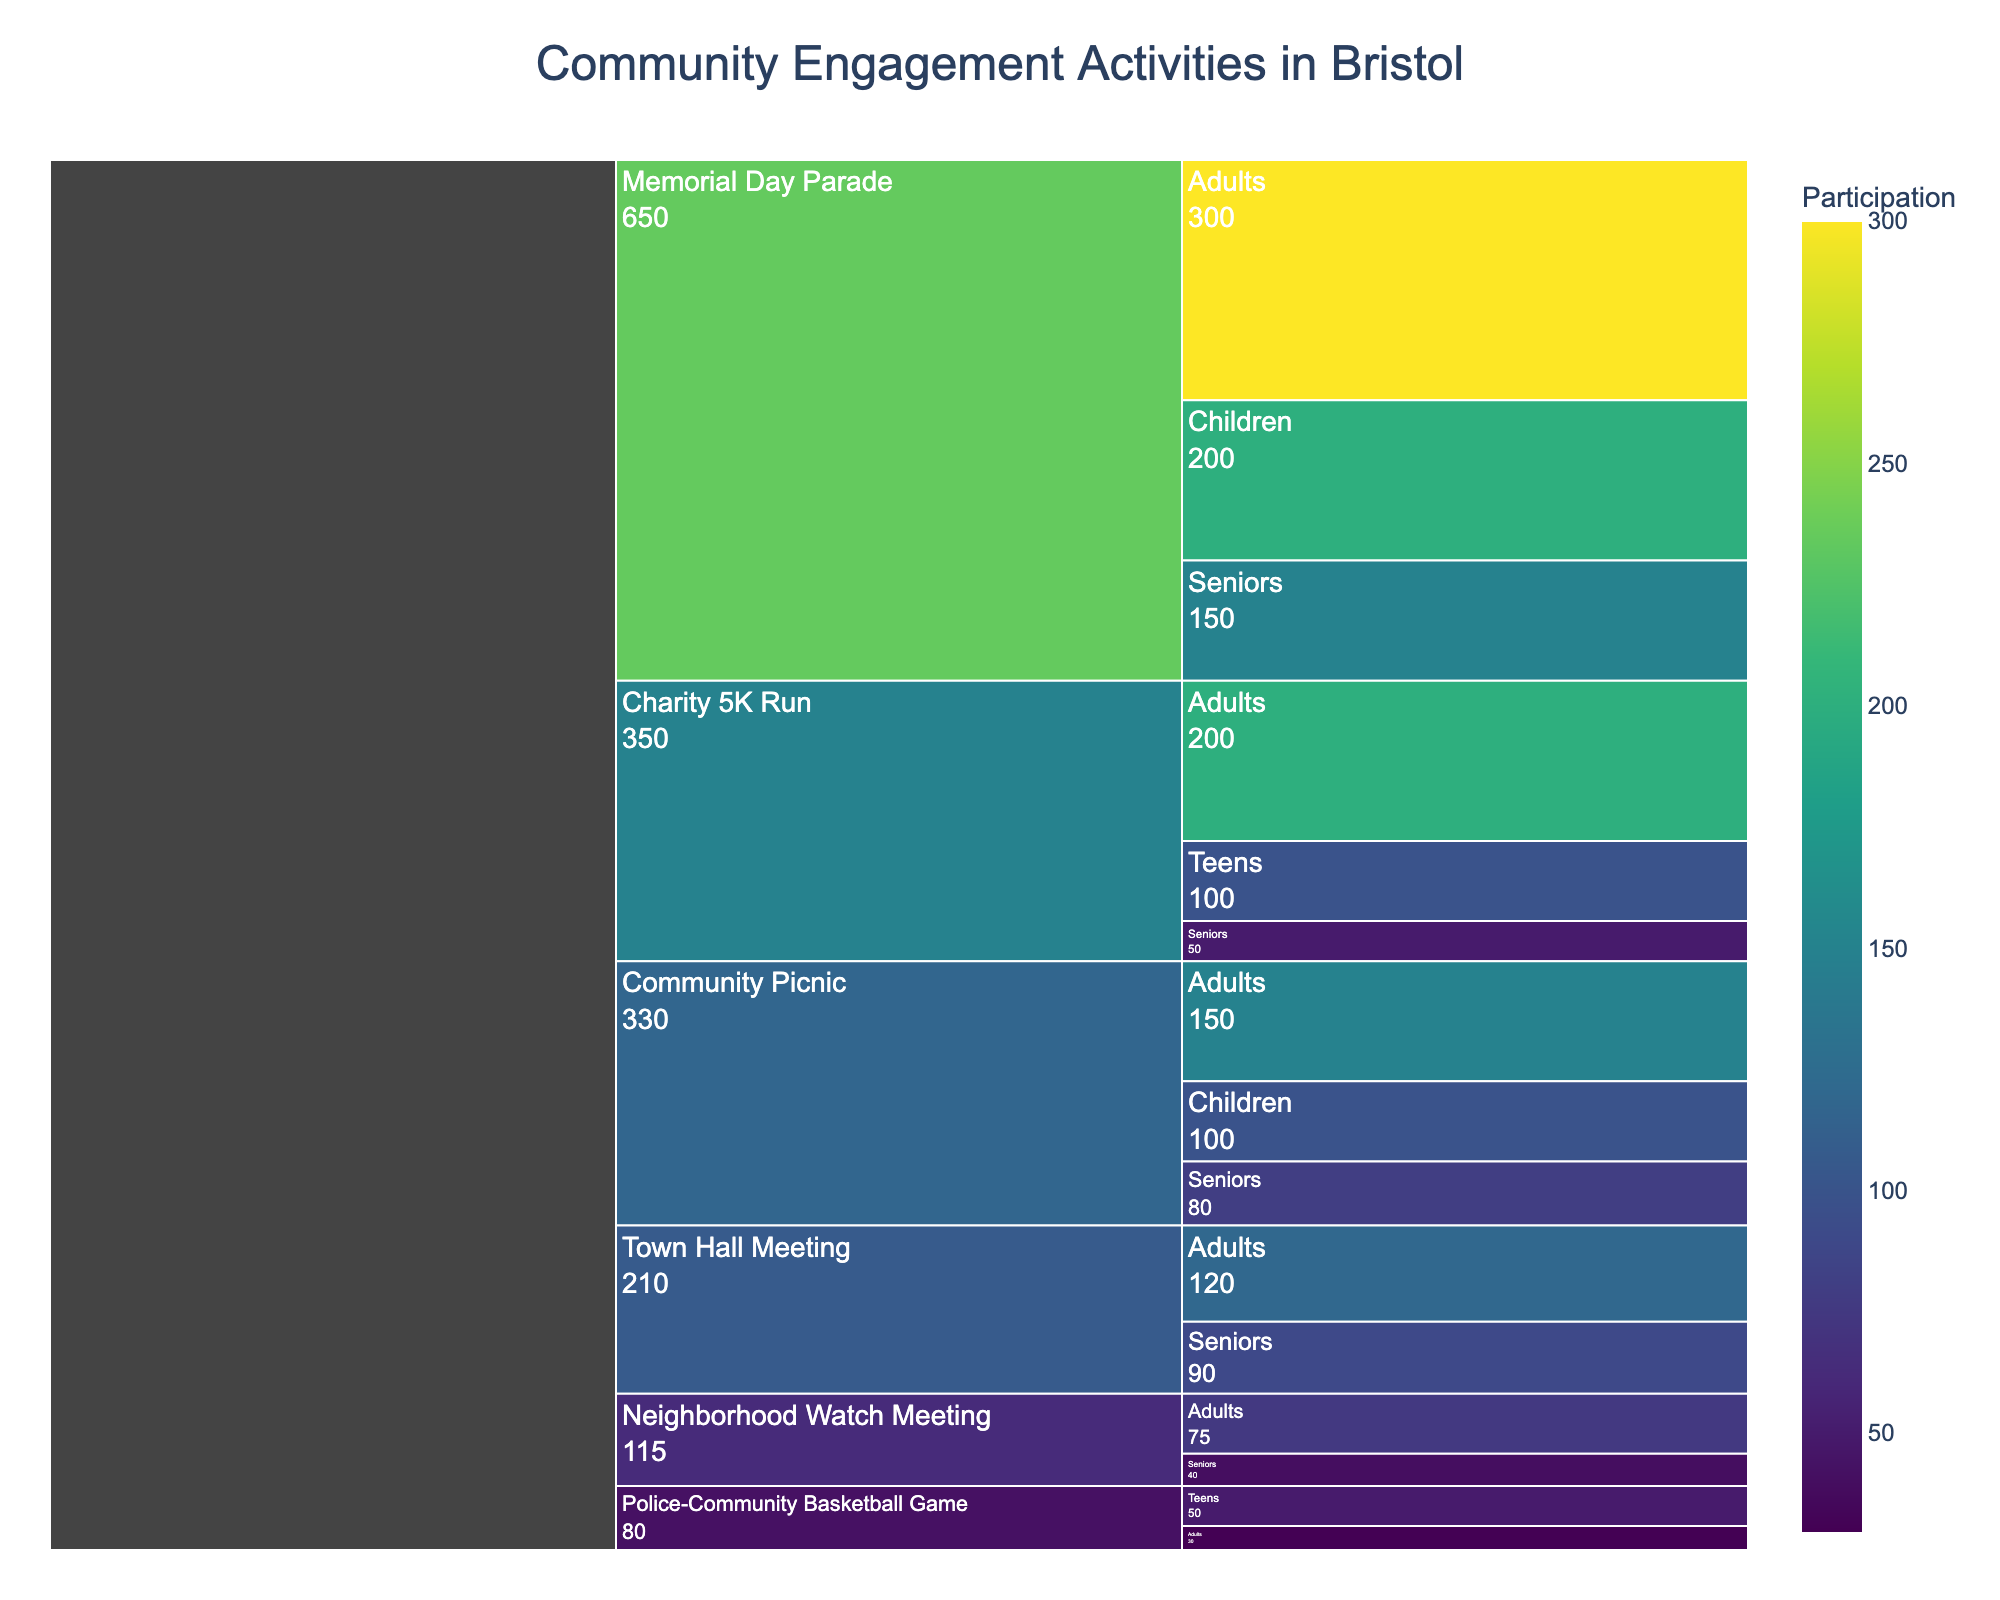What's the title of the chart? The title of the chart is usually clearly displayed at the top of the figure.
Answer: Community Engagement Activities in Bristol Which event has the highest number of total participants? By summing up the participants across different age groups for each event, we find the event with the largest total. The Memorial Day Parade has 300 (Adults) + 150 (Seniors) + 200 (Children) = 650 participants.
Answer: Memorial Day Parade Which age group had more participants in the Community Picnic, Adults or Children? The number of participants for Adults is 150 and for Children is 100. Since 150 is greater than 100, Adults had more participants.
Answer: Adults Which age group shows the highest participation in the Charity 5K Run? The chart indicates the participation count for each age group involved in the Charity 5K Run; Adults have the highest count with 200 participants.
Answer: Adults Compare the number of participants in the Police-Community Basketball Game between Adults and Teens. Who had more participants? The Police-Community Basketball Game shows 30 participants for Adults and 50 participants for Teens. Since 50 is greater than 30, Teens had more participants.
Answer: Teens What is the total number of participants for the Town Hall Meeting? Summing the participants across all age groups for the Town Hall Meeting gives 120 (Adults) + 90 (Seniors) = 210.
Answer: 210 If each event is represented by a different color intensity based on participation count, which event would likely have the darkest shade overall? The event with the highest total participation, which is the Memorial Day Parade with 650 participants, would have the darkest shade.
Answer: Memorial Day Parade How does participation in the Neighborhood Watch Meeting compare between Adults and Seniors? The chart shows 75 participants for Adults and 40 for Seniors in the Neighborhood Watch Meeting. Since 75 is greater than 40, Adults had more participants.
Answer: Adults Rank the events in descending order of total participation. By summing the participants across age groups for each event and comparing, the ranks are: Memorial Day Parade (650), Charity 5K Run (350), Community Picnic (330), Town Hall Meeting (210), Neighborhood Watch Meeting (115), Police-Community Basketball Game (80).
Answer: Memorial Day Parade, Charity 5K Run, Community Picnic, Town Hall Meeting, Neighborhood Watch Meeting, Police-Community Basketball Game Which event types have participation counts over 300? Events which, when summed across age groups, exceed 300 are the Memorial Day Parade (650) and Charity 5K Run (350).
Answer: Memorial Day Parade, Charity 5K Run 